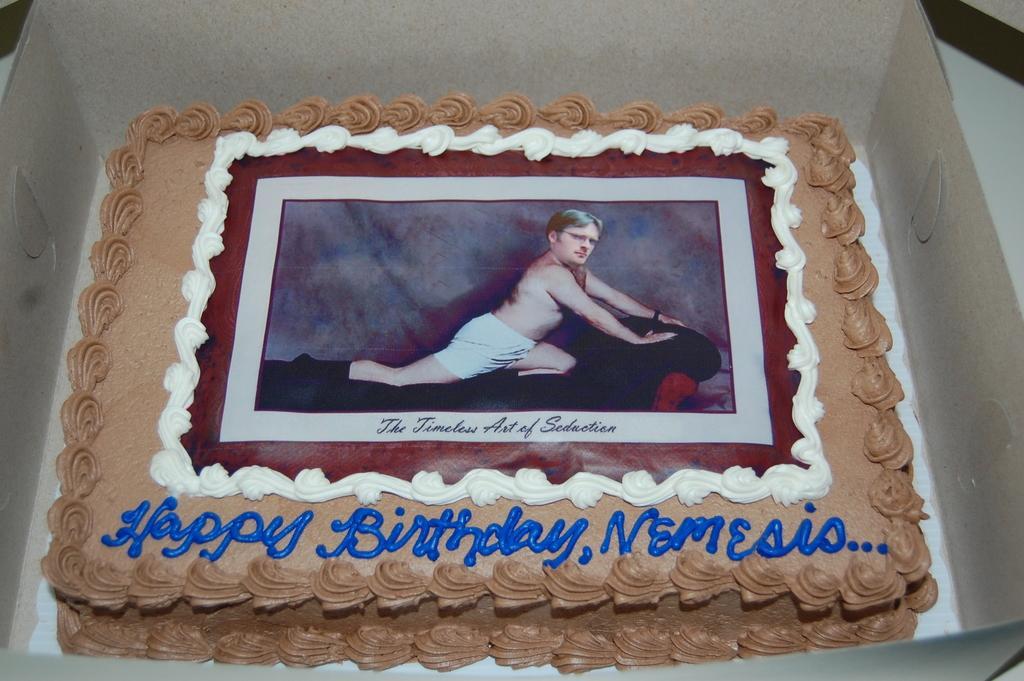Can you describe this image briefly? In this picture we can see a cake in a box, on this cake we can see image of a man and text. 